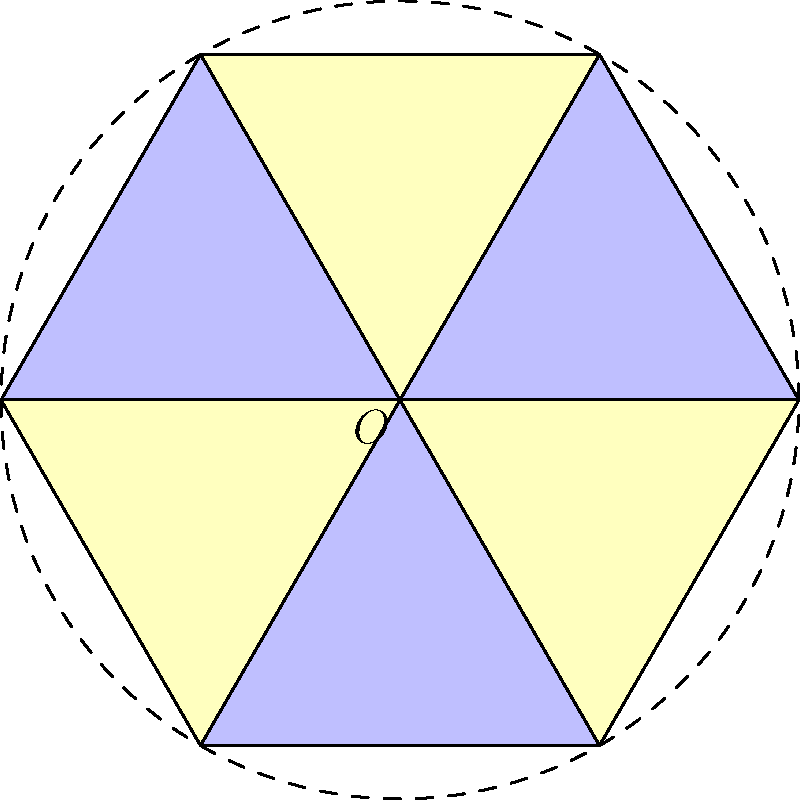In the traditional Japanese geometric pattern shown above, which symmetry group best describes the rotational and reflectional symmetries of the hexagonal design? To determine the symmetry group of this hexagonal pattern, we need to analyze its rotational and reflectional symmetries:

1. Rotational symmetry:
   - The pattern has 6-fold rotational symmetry, meaning it can be rotated by 60°, 120°, 180°, 240°, 300°, and 360° (full rotation) around the center point O.

2. Reflectional symmetry:
   - The pattern has 6 lines of reflection, passing through the center and each vertex, as well as through the center and the midpoint of each side.

3. Symmetry operations:
   - 6 rotations (including the identity rotation)
   - 6 reflections

4. Total number of symmetry operations: 12

5. Identifying the symmetry group:
   - The presence of both rotational and reflectional symmetries, along with the specific number of operations, indicates that this pattern belongs to the dihedral group $D_6$.

The dihedral group $D_6$ is the symmetry group of a regular hexagon, which perfectly describes the symmetries observed in this traditional Japanese geometric pattern.
Answer: $D_6$ (Dihedral group of order 12) 